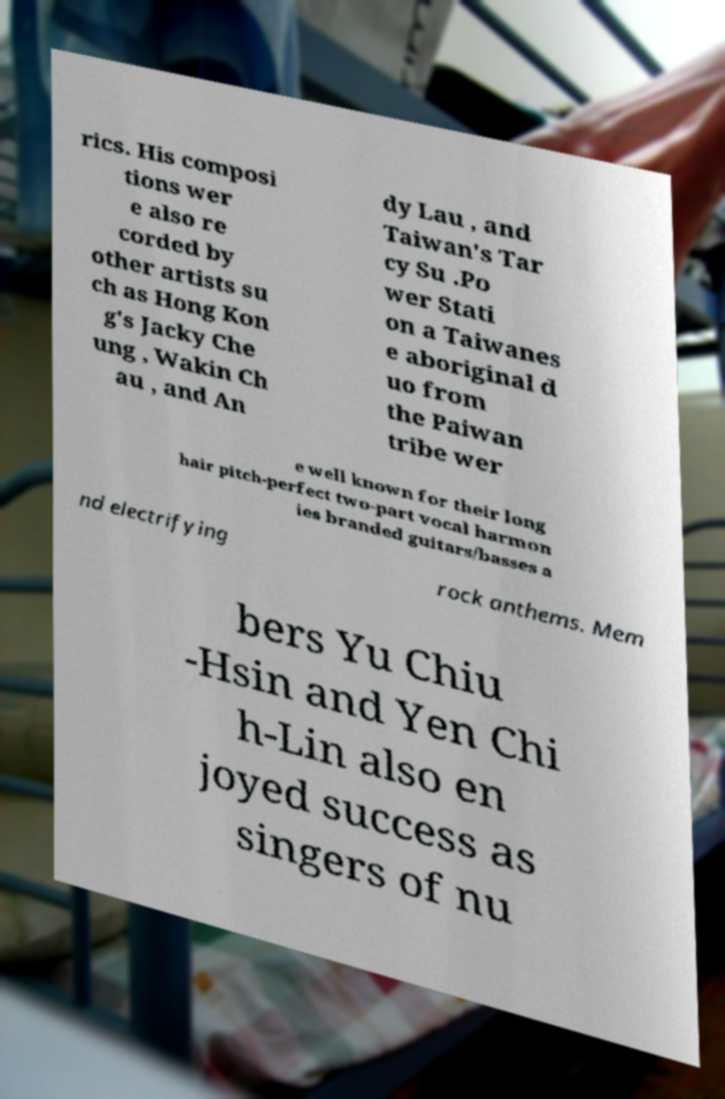There's text embedded in this image that I need extracted. Can you transcribe it verbatim? rics. His composi tions wer e also re corded by other artists su ch as Hong Kon g's Jacky Che ung , Wakin Ch au , and An dy Lau , and Taiwan's Tar cy Su .Po wer Stati on a Taiwanes e aboriginal d uo from the Paiwan tribe wer e well known for their long hair pitch-perfect two-part vocal harmon ies branded guitars/basses a nd electrifying rock anthems. Mem bers Yu Chiu -Hsin and Yen Chi h-Lin also en joyed success as singers of nu 